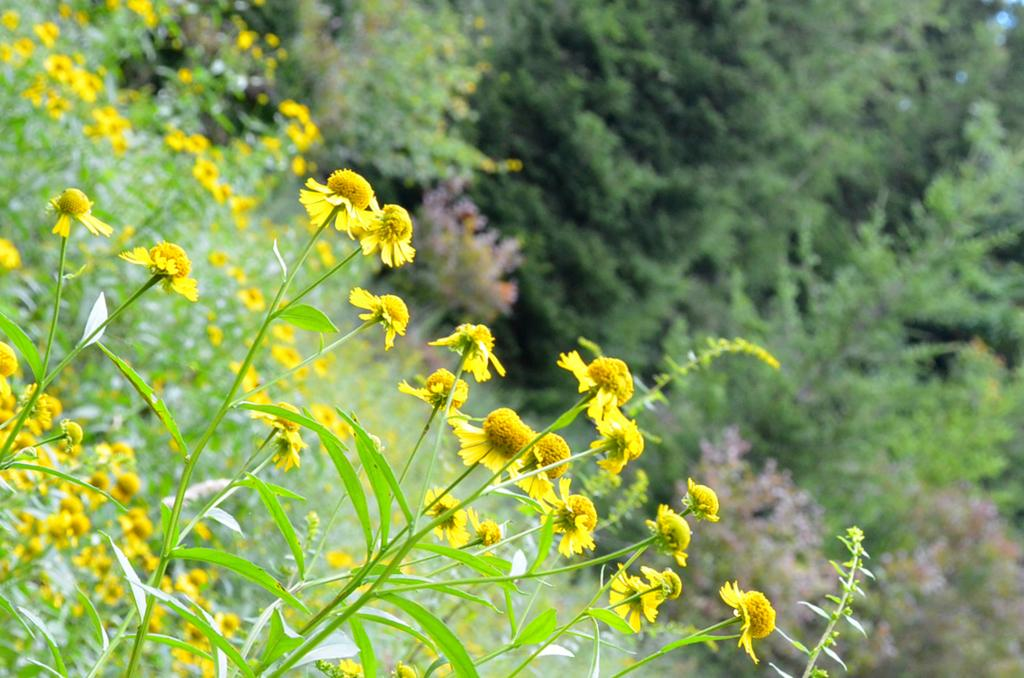Where might the image have been taken? The image might be taken from outside of the city. What can be seen on the left side of the image? There is a plant with yellow flowers on the left side of the image. What type of vegetation is on the right side of the image? There are trees on the right side of the image. How many legs can be seen on the tray in the image? There is no tray present in the image, so it is not possible to determine the number of legs. 